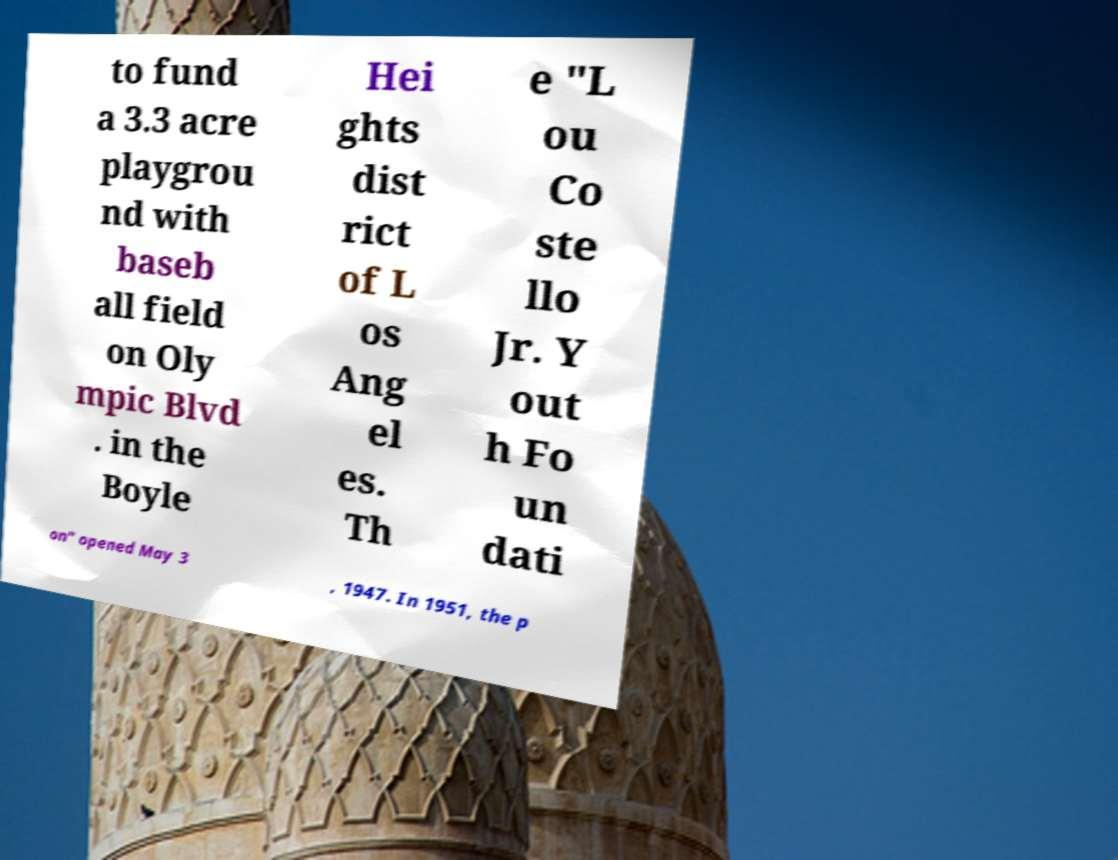Can you read and provide the text displayed in the image?This photo seems to have some interesting text. Can you extract and type it out for me? to fund a 3.3 acre playgrou nd with baseb all field on Oly mpic Blvd . in the Boyle Hei ghts dist rict of L os Ang el es. Th e "L ou Co ste llo Jr. Y out h Fo un dati on" opened May 3 , 1947. In 1951, the p 